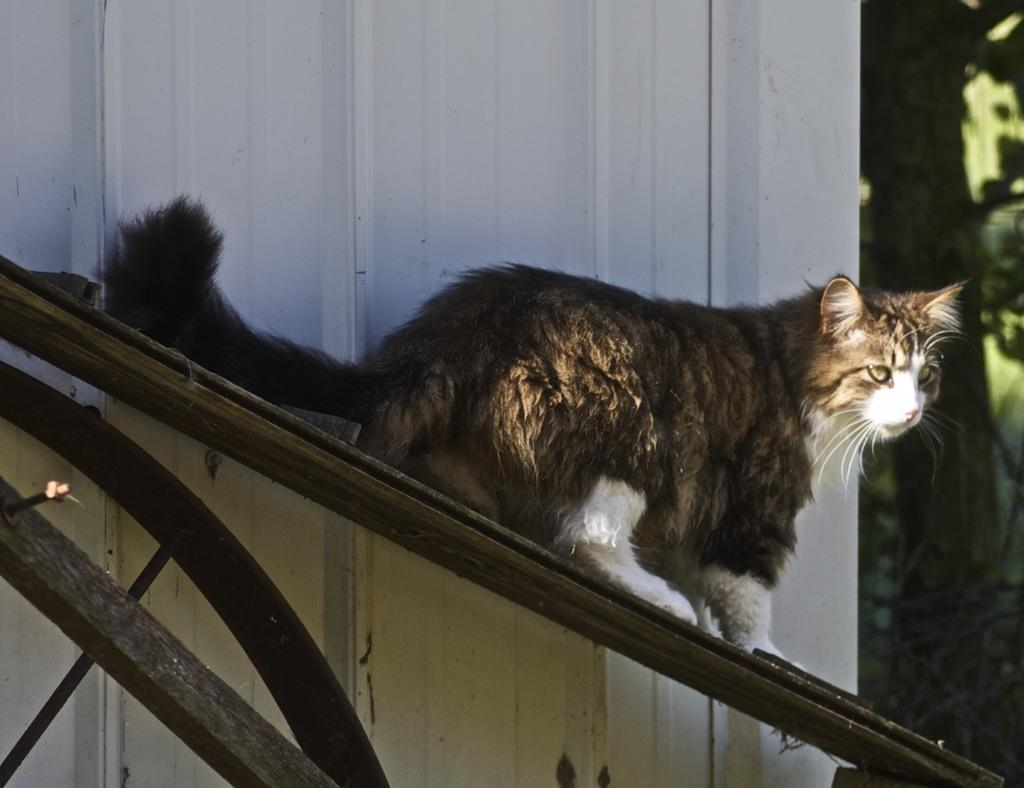What animal is present in the image? There is a cat in the image. What is the cat sitting on? The cat is on a wooden object. What colors can be seen on the cat? The cat has brown, black, and white colors. What color is the object in the image? There is a white color object in the image. What can be seen in the background of the image? The background of the image is green. What type of weather can be seen in the image? The provided facts do not mention any weather conditions, so it cannot be determined from the image. Can you point to the spark in the image? There is no spark present in the image. 